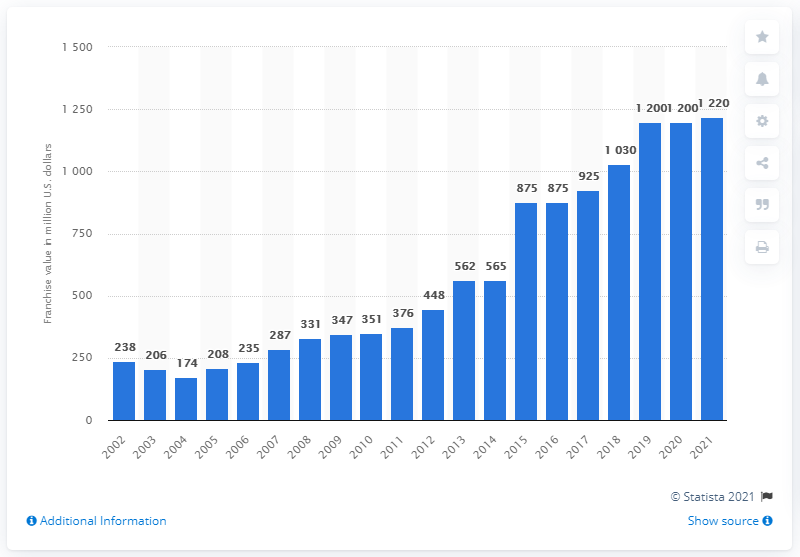Indicate a few pertinent items in this graphic. According to estimates, the value of the Milwaukee Brewers in 2021 was approximately 1,220. 